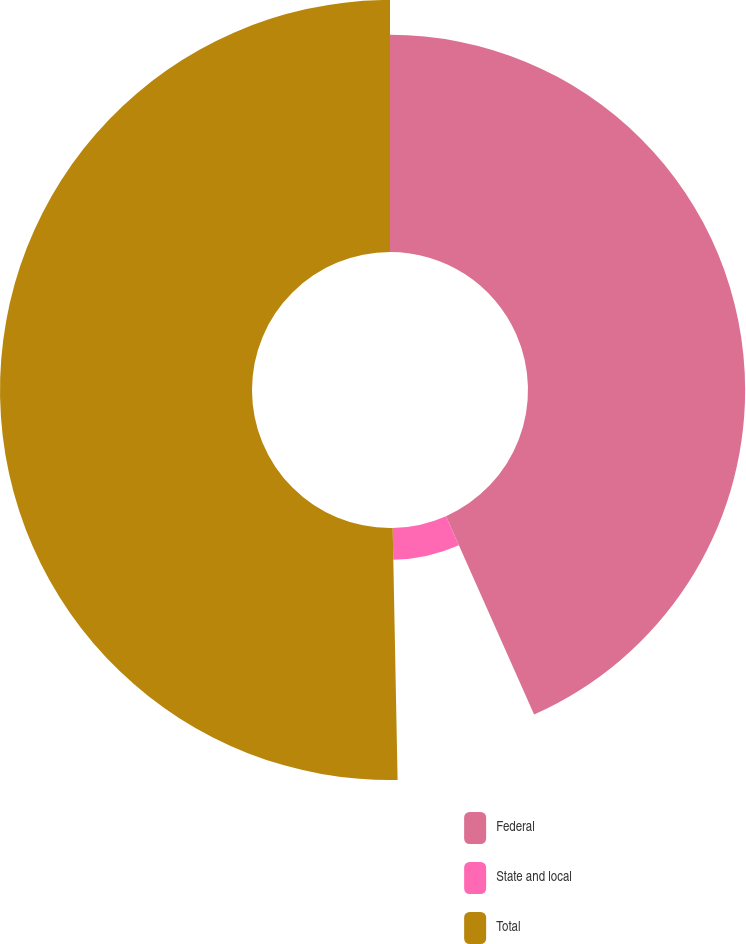<chart> <loc_0><loc_0><loc_500><loc_500><pie_chart><fcel>Federal<fcel>State and local<fcel>Total<nl><fcel>43.35%<fcel>6.34%<fcel>50.31%<nl></chart> 